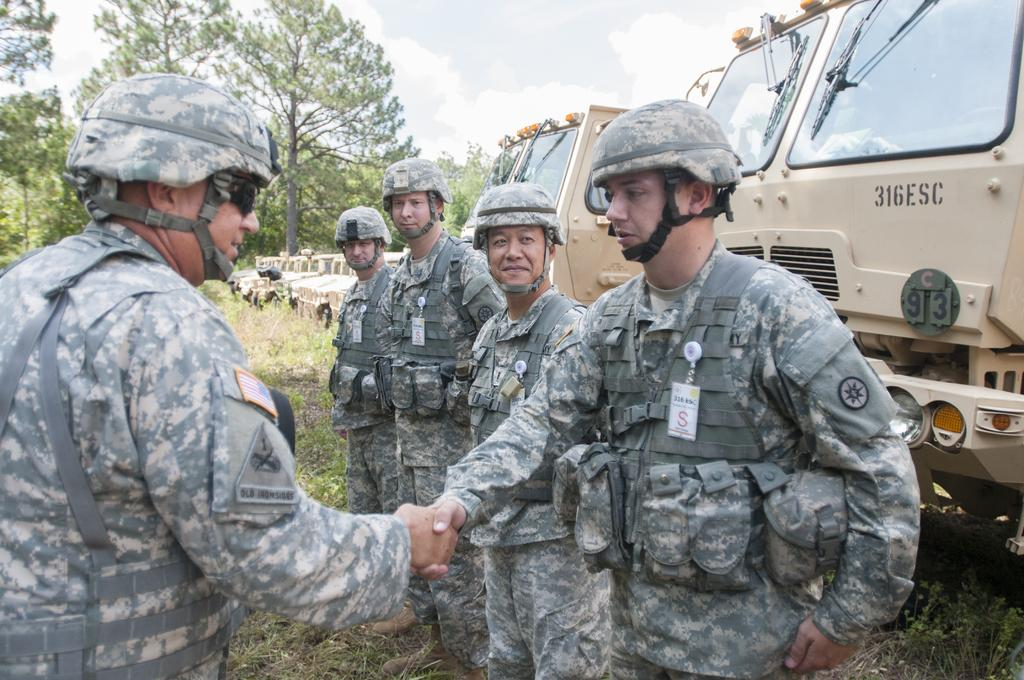<image>
Provide a brief description of the given image. Soldiers standing in front of large vehicles with numbers 316ESC 